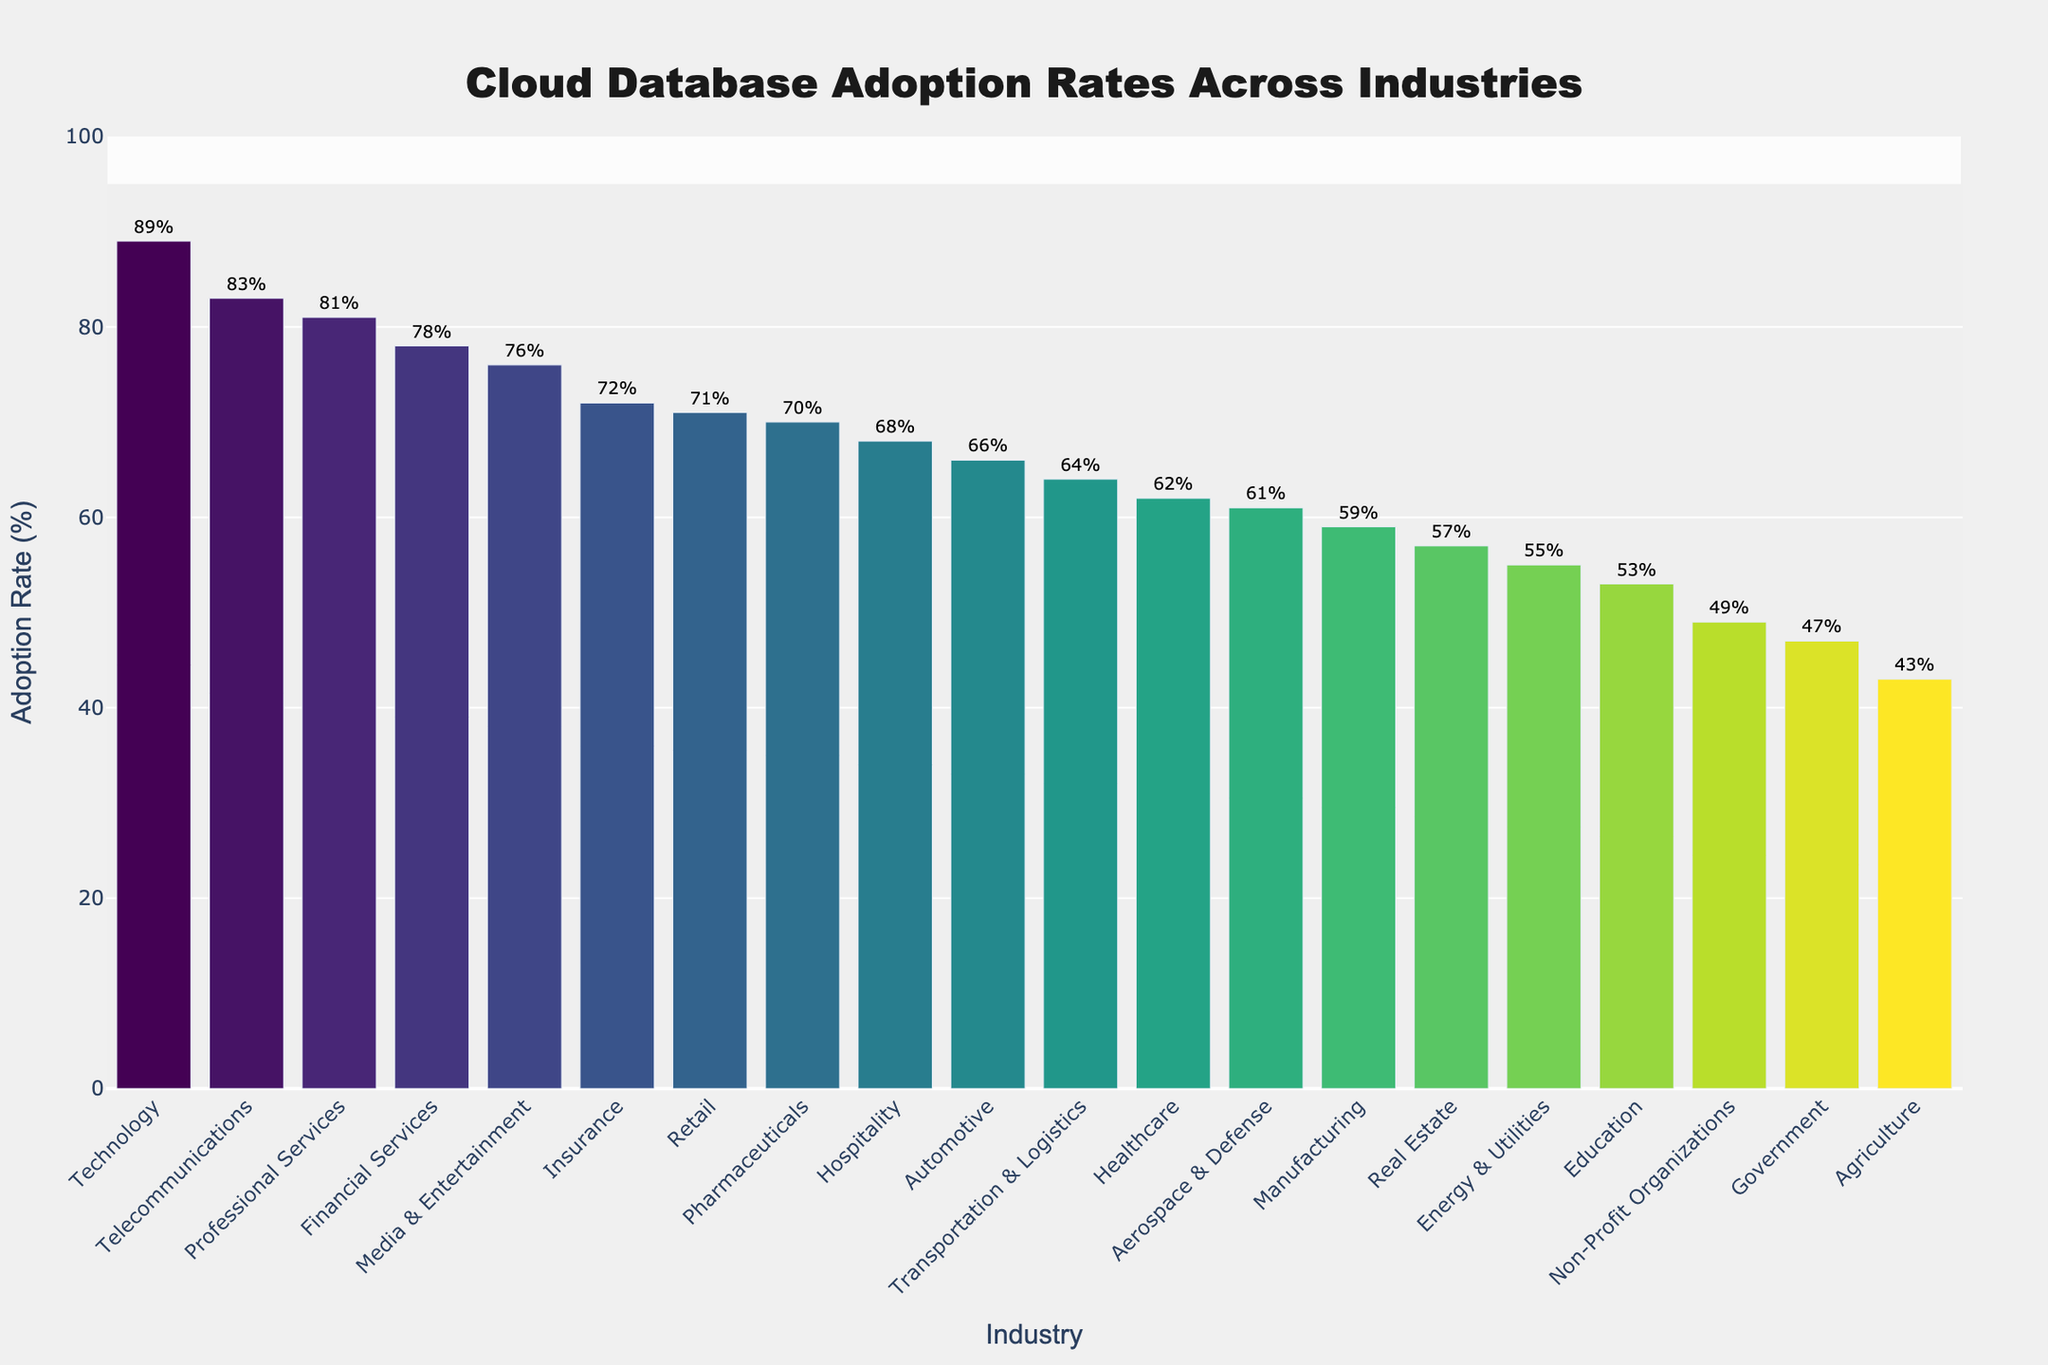Which industry has the highest adoption rate for cloud databases? The figure shows the adoption rates of various industries as a bar chart, sorted in descending order. The highest bar represents the industry with the highest adoption rate.
Answer: Technology Which industries have an adoption rate below 50%? The figure shows bars representing adoption rates, with a y-axis range from 0 to 100%. By examining which bars fall below the 50% line, the following industries are identified: Government, Agriculture, and Non-Profit Organizations.
Answer: Government, Agriculture, Non-Profit Organizations How much higher is the adoption rate for the Technology industry compared to the Agriculture industry? The figure shows the adoption rate for the Technology industry is 89% and for the Agriculture industry is 43%. Subtracting these two rates gives the difference.
Answer: 46% What is the median adoption rate across all industries? To find the median, list all the adoption rates in ascending order and locate the middle value. The rates are: 43, 47, 49, 53, 55, 57, 59, 61, 62, 64, 66, 68, 70, 71, 72, 76, 78, 81, 83, 89. The median is between the 10th and 11th values.
Answer: 64% Which three industries have the closest adoption rates, and what are those rates? By examining the figure, look for adjacent bars of similar heights. The Healthcare (62%), Aerospace & Defense (61%), and Transportation & Logistics (64%) industries have close adoption rates.
Answer: Healthcare (62%), Aerospace & Defense (61%), Transportation & Logistics (64%) Identify industries with adoption rates greater than 75% but less than 85%. By examining the bars with respect to the y-axis values, industries falling within these constraints are identified: Financial Services (78%), Media & Entertainment (76%), and Telecommunications (83%).
Answer: Financial Services, Media & Entertainment, Telecommunications Which has a higher adoption rate, Healthcare or Manufacturing? By comparing the heights of the bars for Healthcare and Manufacturing industries, Healthcare (62%) is higher than Manufacturing (59%).
Answer: Healthcare How many industries have an adoption rate above the overall average rate? First, calculate the average adoption rate by summing all rates and dividing by the number of industries. Then count the bars above this average. The average rate is 65.1%; industries above this average are: Technology, Telecommunications, Professional Services, Financial Services, Media & Entertainment, Retail, and Insurance.
Answer: 7 What's the average adoption rate of Healthcare, Retail, and Professional Services industries? The respective adoption rates are Healthcare (62%), Retail (71%), Professional Services (81%). Calculating their average: (62 + 71 + 81) / 3 = 71.3%.
Answer: 71.3% Which industry has an adoption rate closest to 60%? By examining the bar heights close to 60%, Aerospace & Defense (61%) is the closest to 60%.
Answer: Aerospace & Defense 